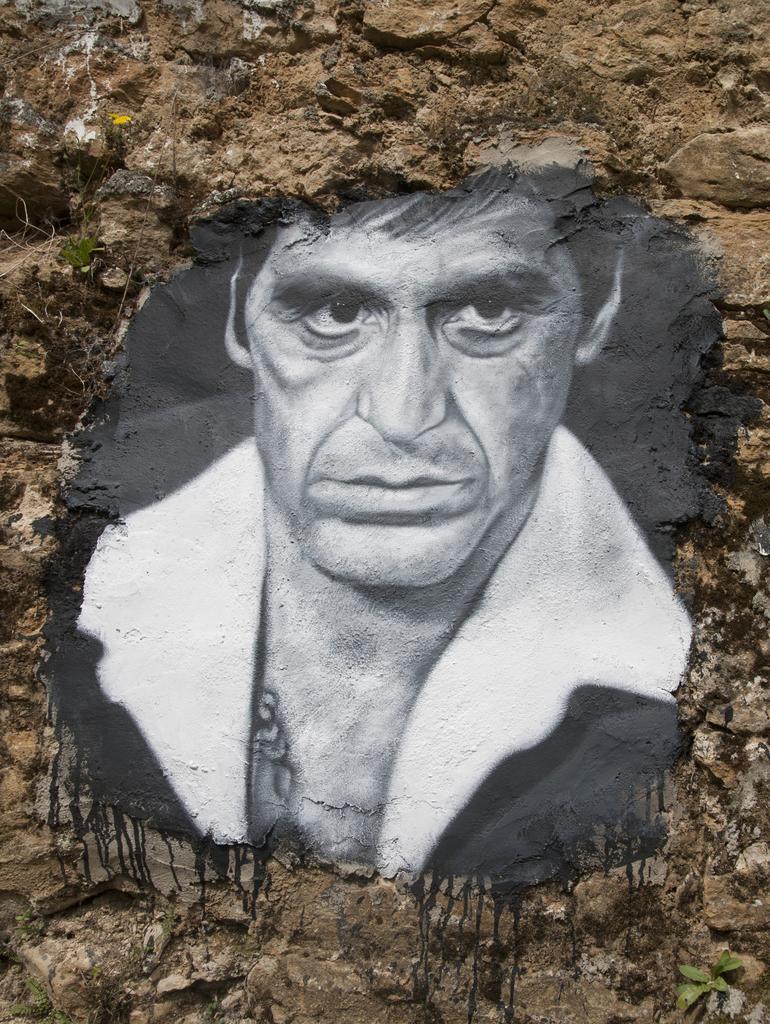Please provide a concise description of this image. In this image there is a painting of a person on a rocky surface as we can see in the middle of this image. 